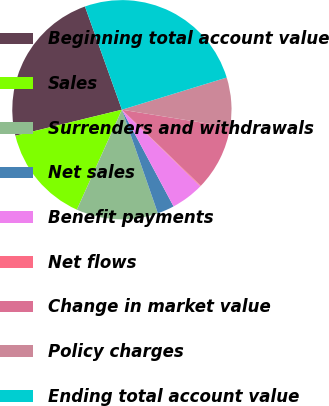Convert chart. <chart><loc_0><loc_0><loc_500><loc_500><pie_chart><fcel>Beginning total account value<fcel>Sales<fcel>Surrenders and withdrawals<fcel>Net sales<fcel>Benefit payments<fcel>Net flows<fcel>Change in market value<fcel>Policy charges<fcel>Ending total account value<nl><fcel>23.34%<fcel>14.45%<fcel>12.06%<fcel>2.49%<fcel>4.88%<fcel>0.1%<fcel>9.67%<fcel>7.28%<fcel>25.73%<nl></chart> 